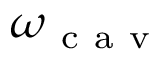<formula> <loc_0><loc_0><loc_500><loc_500>\omega _ { c a v }</formula> 